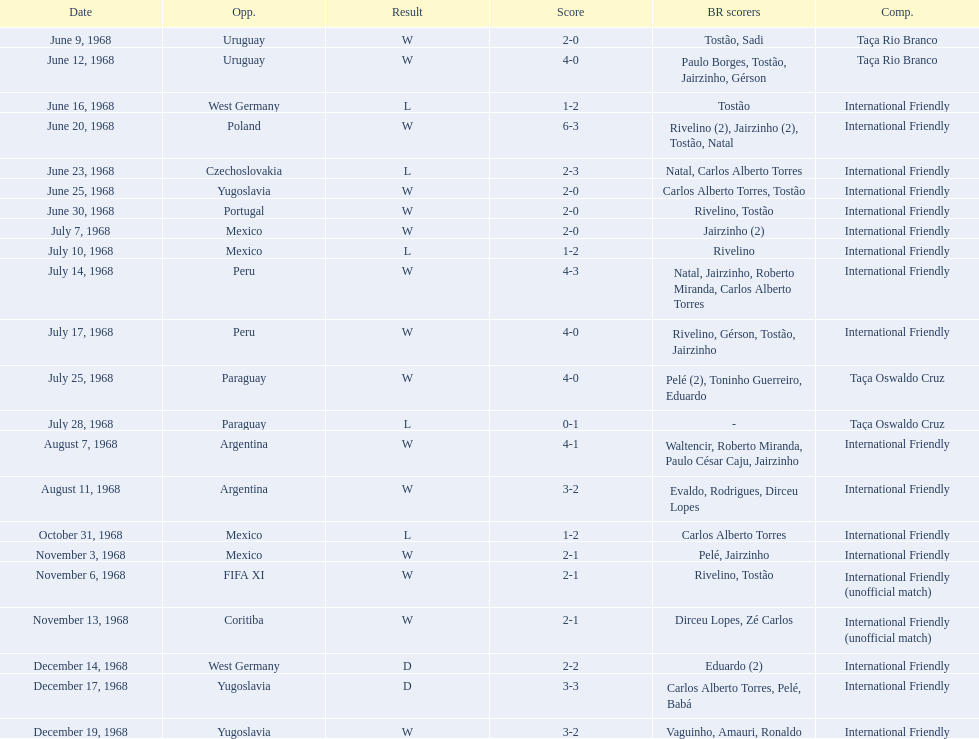Name the first competition ever played by brazil. Taça Rio Branco. 